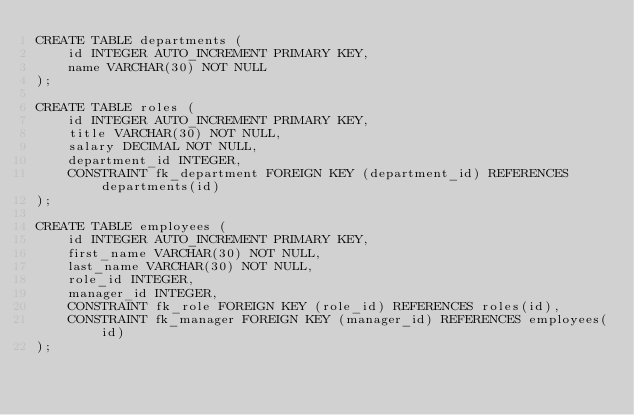Convert code to text. <code><loc_0><loc_0><loc_500><loc_500><_SQL_>CREATE TABLE departments (
    id INTEGER AUTO_INCREMENT PRIMARY KEY,
    name VARCHAR(30) NOT NULL
);

CREATE TABLE roles (
    id INTEGER AUTO_INCREMENT PRIMARY KEY,
    title VARCHAR(30) NOT NULL,
    salary DECIMAL NOT NULL,
    department_id INTEGER,
    CONSTRAINT fk_department FOREIGN KEY (department_id) REFERENCES departments(id)
);

CREATE TABLE employees (
    id INTEGER AUTO_INCREMENT PRIMARY KEY,
    first_name VARCHAR(30) NOT NULL,
    last_name VARCHAR(30) NOT NULL,
    role_id INTEGER,
    manager_id INTEGER,
    CONSTRAINT fk_role FOREIGN KEY (role_id) REFERENCES roles(id),
    CONSTRAINT fk_manager FOREIGN KEY (manager_id) REFERENCES employees(id)
);</code> 